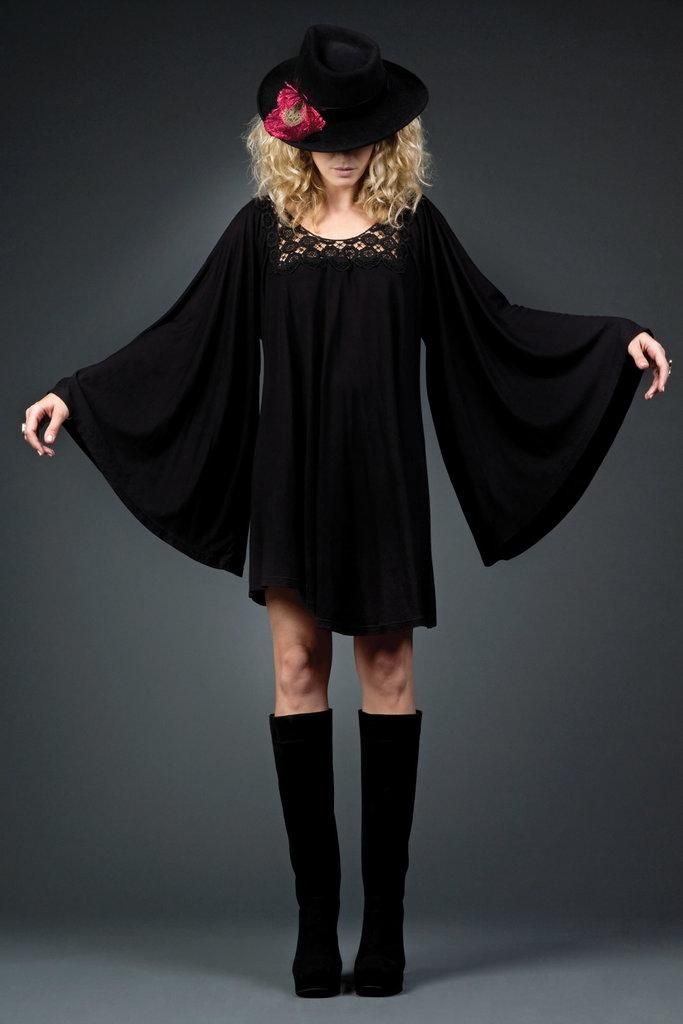Who is present in the image? There is a woman in the image. What is the woman doing in the image? The woman is standing in the image. What is the woman wearing on her head? The woman is wearing a black hat with a red color thing on it. What is the woman wearing on her body? The woman is wearing a black dress. What is the woman wearing on her feet? The woman is wearing black shoes. What type of basketball design can be seen on the woman's dress? There is no basketball design present on the woman's dress; it is a black dress without any visible designs. How many pies is the woman holding in the image? There are no pies present in the image; the woman is not holding any pies. 